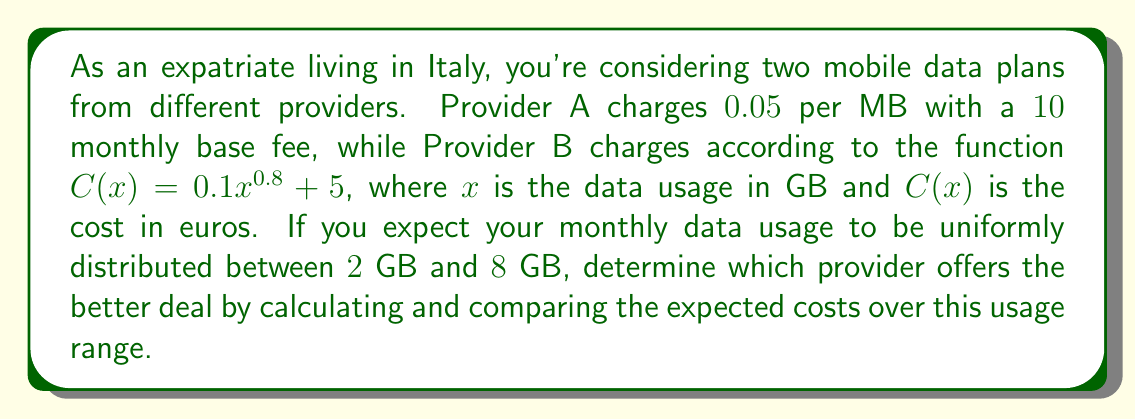Solve this math problem. To solve this problem, we need to calculate the expected cost for each provider over the given usage range and compare them.

1. Provider A:
   The cost function for Provider A is linear: $C_A(x) = 0.05 \cdot 1000x + 10$, where $x$ is in GB.
   To find the expected cost, we integrate this function over the range and divide by the range:

   $$E(C_A) = \frac{1}{8-2} \int_2^8 (0.05 \cdot 1000x + 10) dx$$
   $$= \frac{1}{6} \left[ 50x^2 + 10x \right]_2^8$$
   $$= \frac{1}{6} \left[ (3200 + 80) - (200 + 20) \right]$$
   $$= \frac{3060}{6} = €51$$

2. Provider B:
   The cost function is $C_B(x) = 0.1x^{0.8} + 5$
   Similarly, we integrate this function:

   $$E(C_B) = \frac{1}{8-2} \int_2^8 (0.1x^{0.8} + 5) dx$$
   $$= \frac{1}{6} \left[ \frac{0.1 \cdot x^{1.8}}{1.8} + 5x \right]_2^8$$
   $$= \frac{1}{6} \left[ (\frac{0.1 \cdot 8^{1.8}}{1.8} + 40) - (\frac{0.1 \cdot 2^{1.8}}{1.8} + 10) \right]$$
   $$\approx \frac{34.62}{6} = €5.77$$
Answer: Provider B offers the better deal with an expected cost of approximately €5.77 per month, compared to €51 for Provider A. 